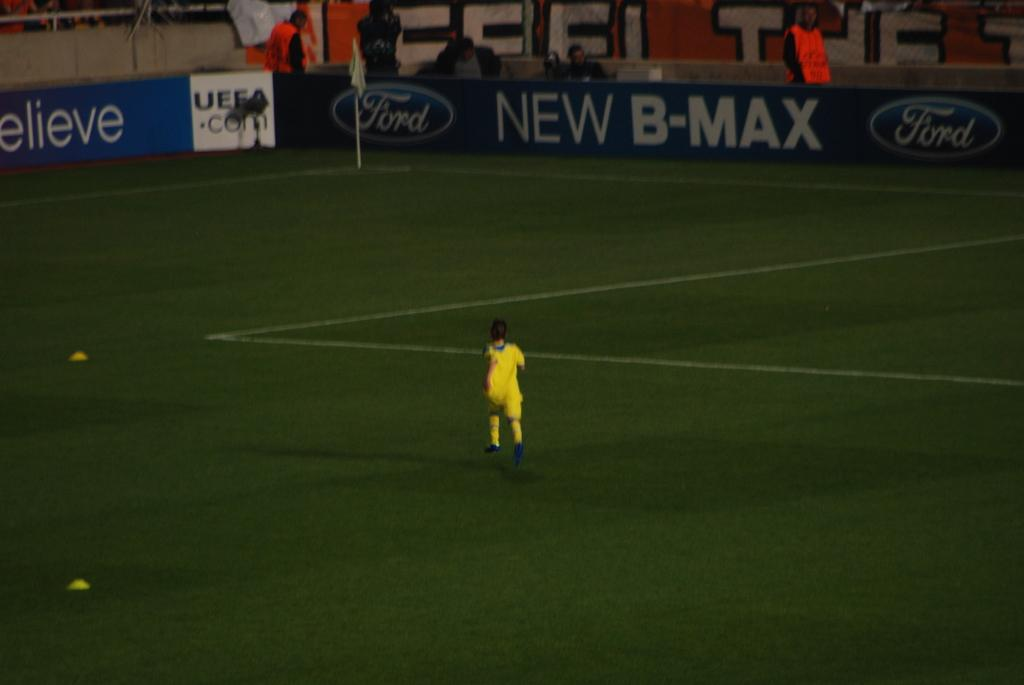<image>
Write a terse but informative summary of the picture. A person dressed in yellow running on the field of the New B-Max field. 